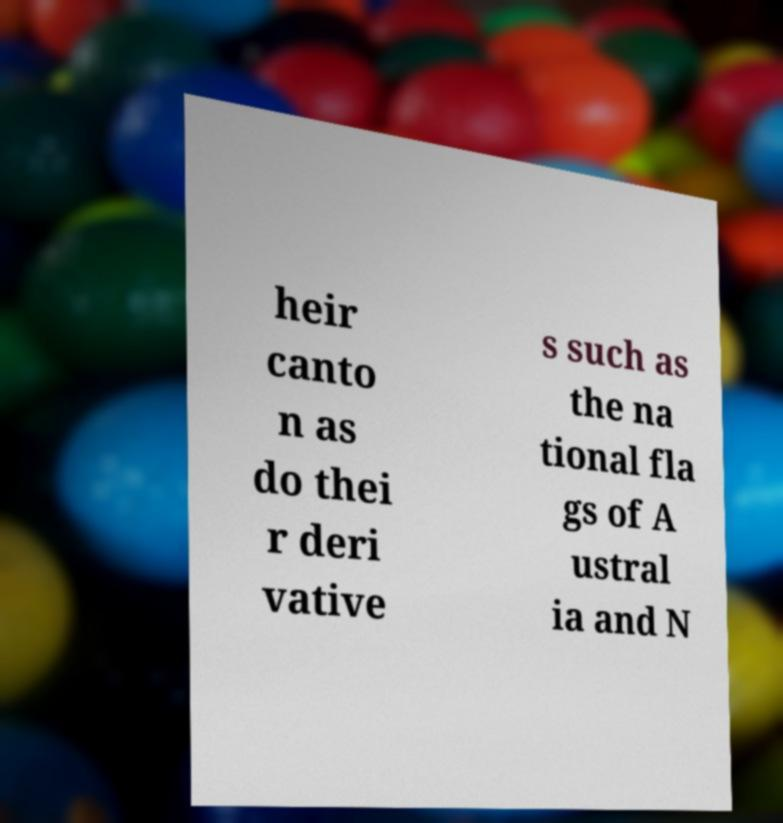Can you accurately transcribe the text from the provided image for me? heir canto n as do thei r deri vative s such as the na tional fla gs of A ustral ia and N 